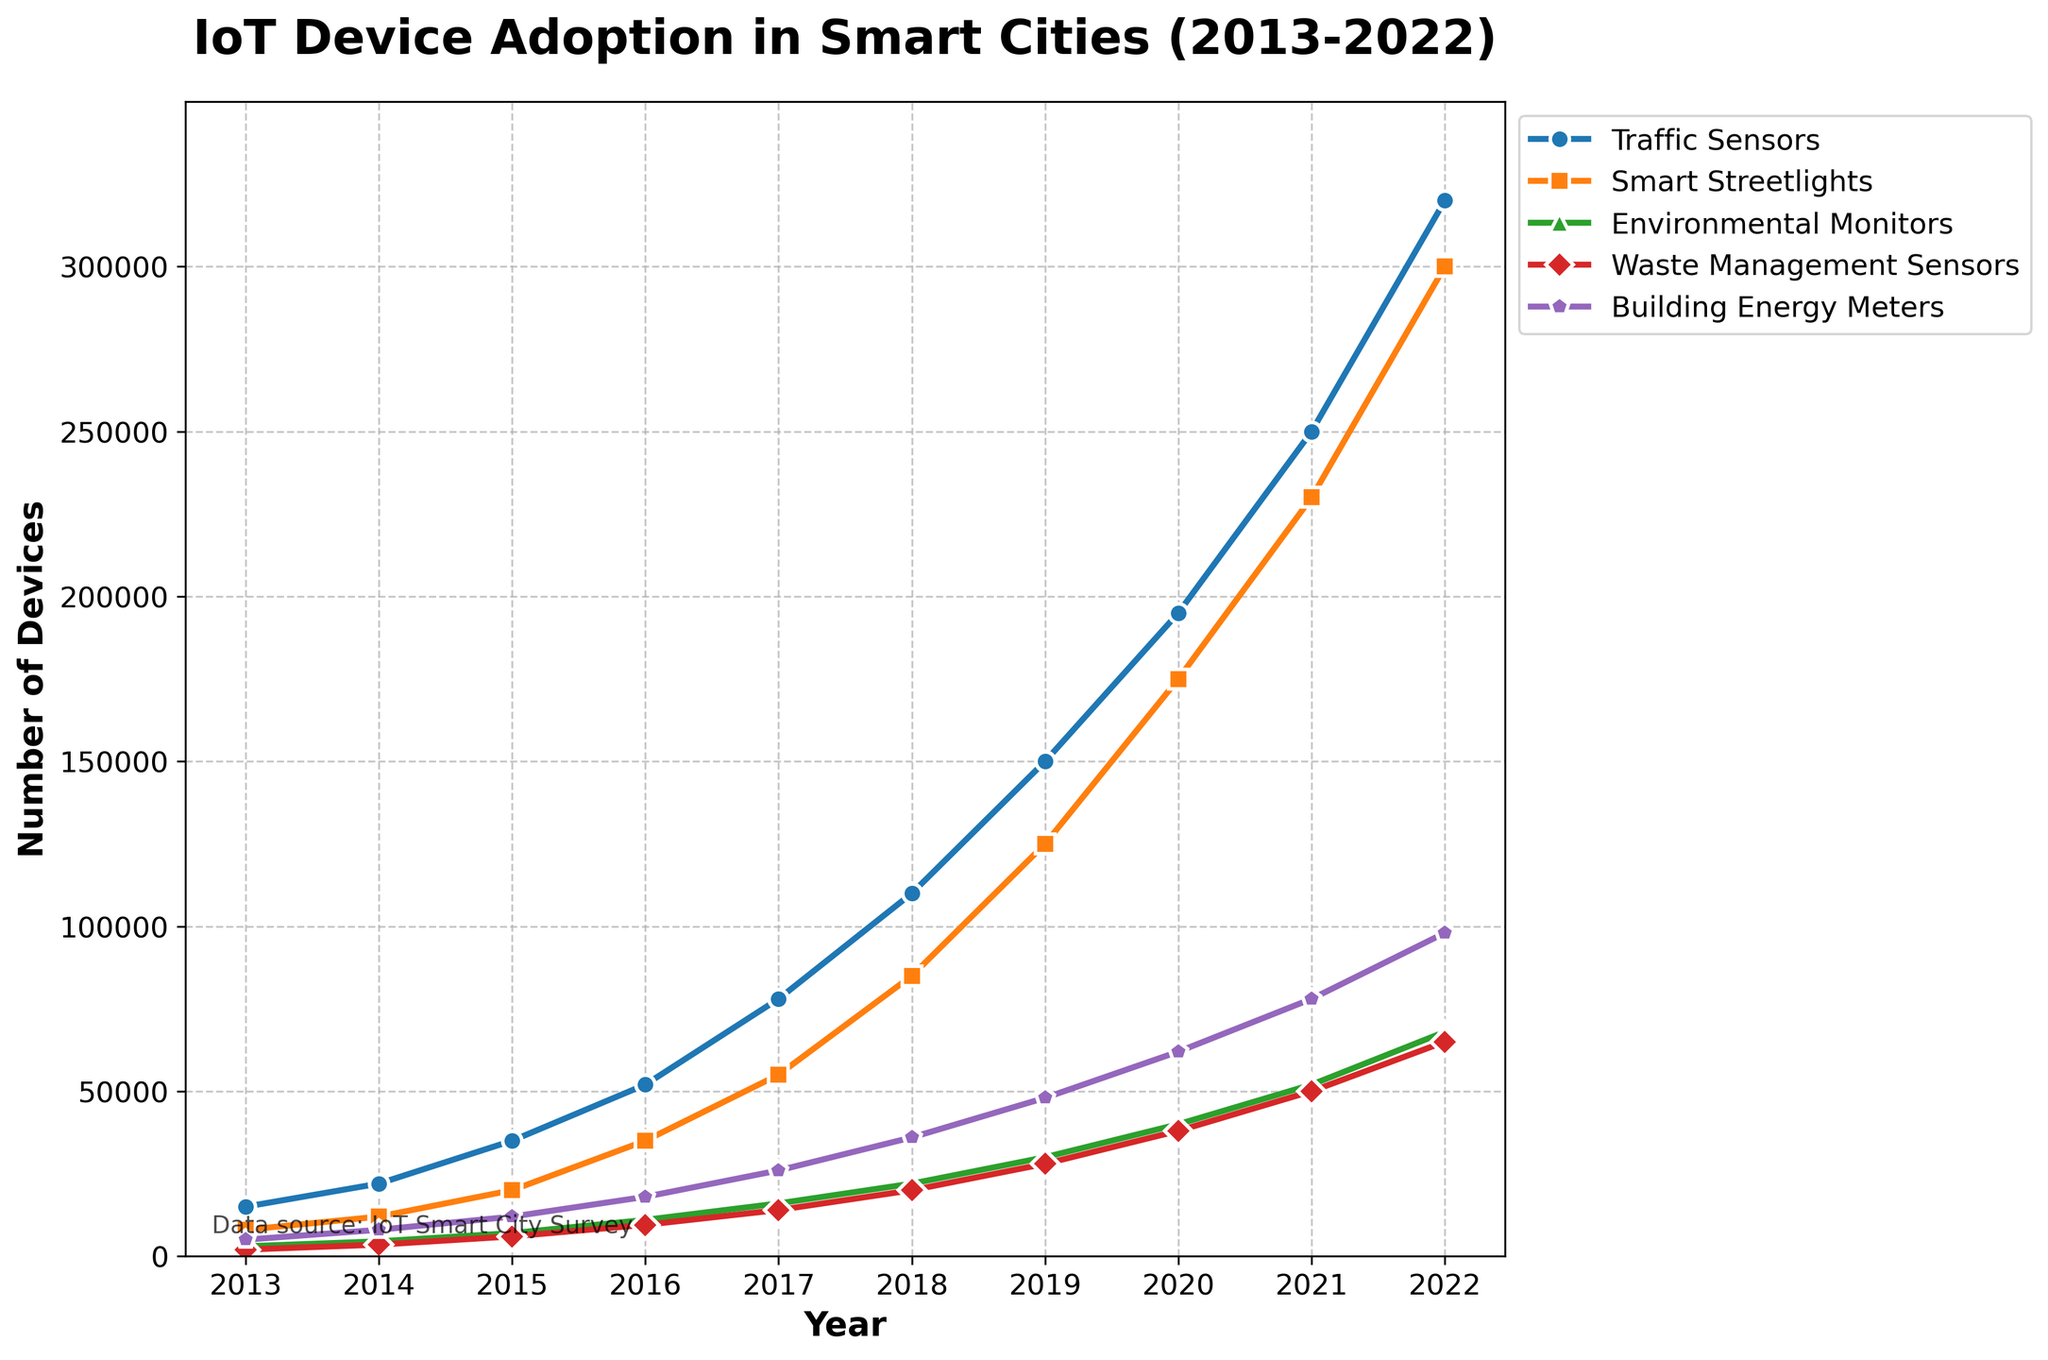How many more Building Energy Meters were there in 2022 compared to 2013? To find the difference, look at the values for Building Energy Meters in 2022 and 2013. In 2022, the value is 98,000, and in 2013, it is 5,000. Subtract the 2013 value from the 2022 value: 98,000 - 5,000 = 93,000.
Answer: 93,000 Which device type had the highest number of adoptions in 2022? Look at the endpoints of the lines for each device type in 2022. The device with the highest y-value in this year is Traffic Sensors with 320,000 devices.
Answer: Traffic Sensors By how much did the number of Smart Streetlights increase from 2017 to 2020? Look at the values for Smart Streetlights in 2017 and 2020. In 2017, it is 55,000 and in 2020, it is 175,000. Subtract the 2017 value from the 2020 value: 175,000 - 55,000 = 120,000.
Answer: 120,000 What is the average number of Environmental Monitors for the years 2019, 2020, and 2021? Look at the values for Environmental Monitors in 2019 (30,000), 2020 (40,000), and 2021 (52,000). Sum these values and divide by 3: (30,000 + 40,000 + 52,000) / 3 = 40,666.67.
Answer: 40,666.67 Which device type had the smallest increase in adoption from 2018 to 2019? Look at the difference in values for each device type between 2018 and 2019. Calculate the differences: Traffic Sensors (150,000 - 110,000 = 40,000), Smart Streetlights (125,000 - 85,000 = 40,000), Environmental Monitors (30,000 - 22,000 = 8,000), Waste Management Sensors (28,000 - 20,000 = 8,000), Building Energy Meters (48,000 - 36,000 = 12,000). The smallest increase is for Environmental Monitors and Waste Management Sensors, both at 8,000.
Answer: Environmental Monitors and Waste Management Sensors Which year had the greatest increase in Traffic Sensors compared to the previous year? Look at the year-on-year differences in Traffic Sensors: 2013 to 2014 (7,000), 2014 to 2015 (13,000), 2015 to 2016 (17,000), 2016 to 2017 (26,000), 2017 to 2018 (32,000), 2018 to 2019 (40,000), 2019 to 2020 (45,000), 2020 to 2021 (55,000), and 2021 to 2022 (70,000). The greatest increase is from 2021 to 2022 with 70,000.
Answer: 2021 to 2022 Among all years, what is the trend of Waste Management Sensors from 2013 to 2022? Observe the line for Waste Management Sensors from 2013 to 2022. The number increases steadily each year from 2,000 in 2013 to 65,000 in 2022.
Answer: Increasing trend What is the difference between the number of Environmental Monitors and Waste Management Sensors in 2022? Look at the values for Environmental Monitors (68,000) and Waste Management Sensors (65,000) in 2022. Subtract the Waste Management Sensors value from the Environmental Monitors value: 68,000 - 65,000 = 3,000.
Answer: 3,000 